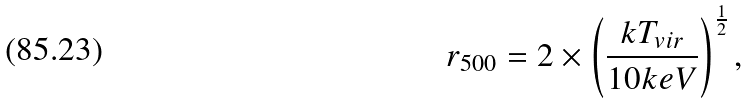Convert formula to latex. <formula><loc_0><loc_0><loc_500><loc_500>r _ { 5 0 0 } = 2 \times \left ( \frac { k T _ { v i r } } { 1 0 k e V } \right ) ^ { \frac { 1 } { 2 } } ,</formula> 